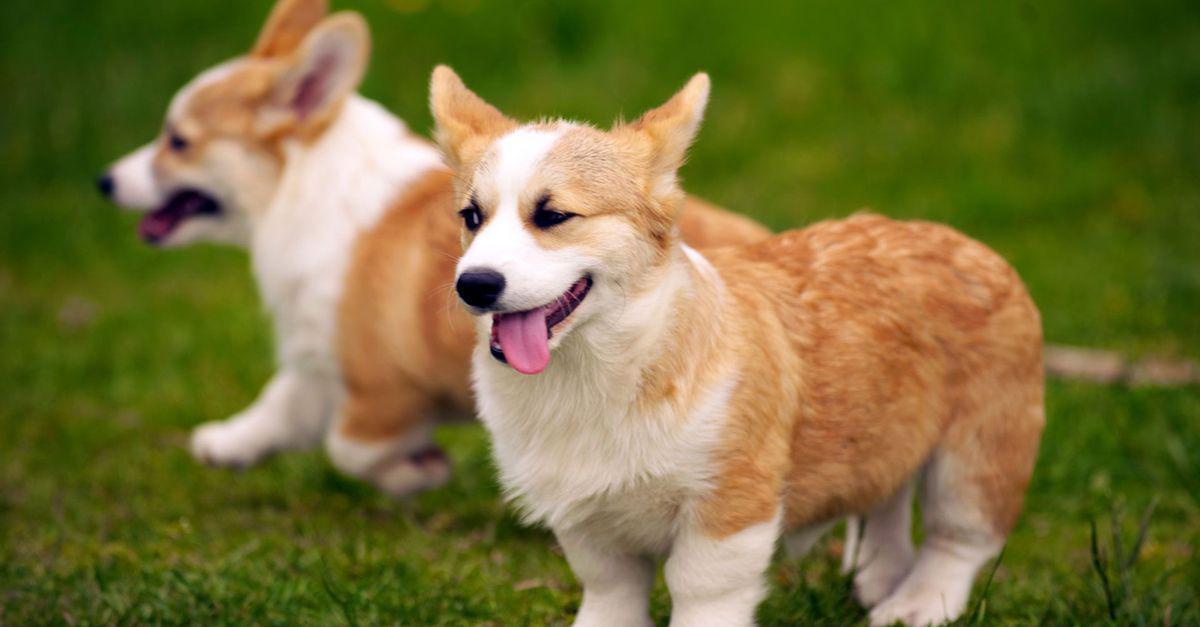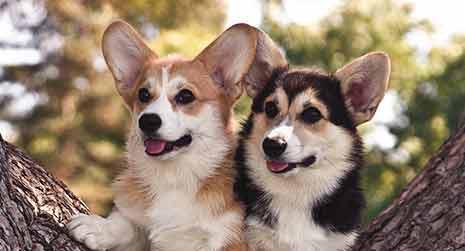The first image is the image on the left, the second image is the image on the right. For the images shown, is this caption "In the image on the right, a dog rests among some flowers." true? Answer yes or no. No. The first image is the image on the left, the second image is the image on the right. Assess this claim about the two images: "The image on the right shows a corgi puppy in the middle of a grassy area with flowers.". Correct or not? Answer yes or no. No. 